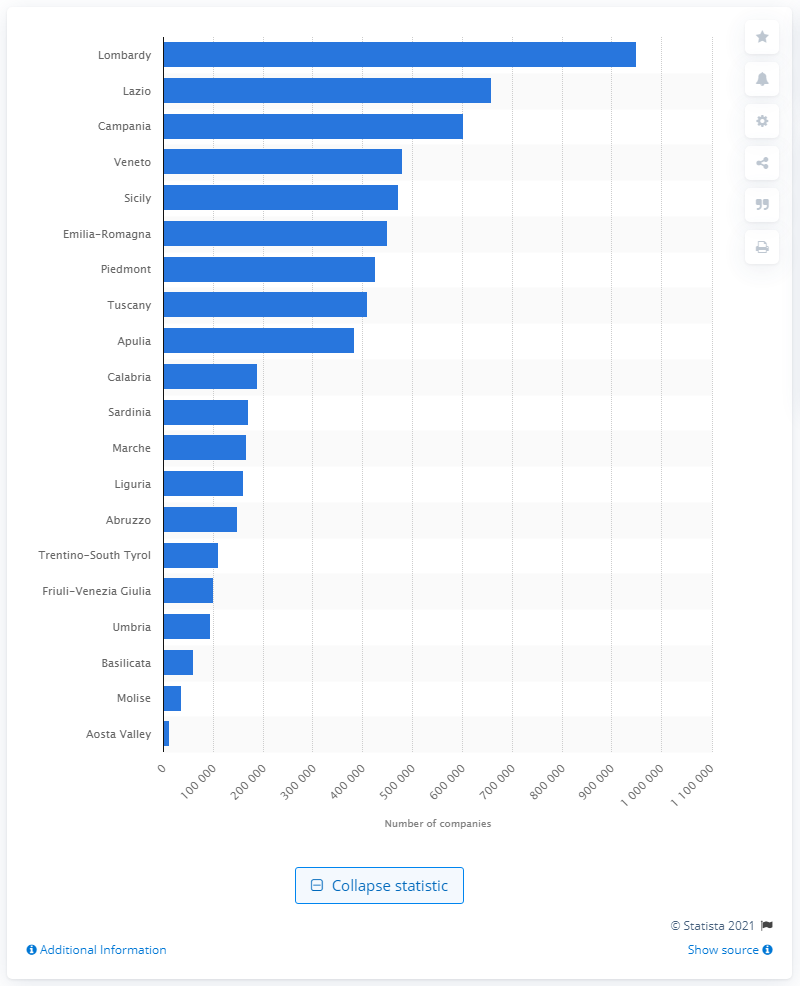Mention a couple of crucial points in this snapshot. Lombardy, an Italian region, has the highest number of enterprises. 